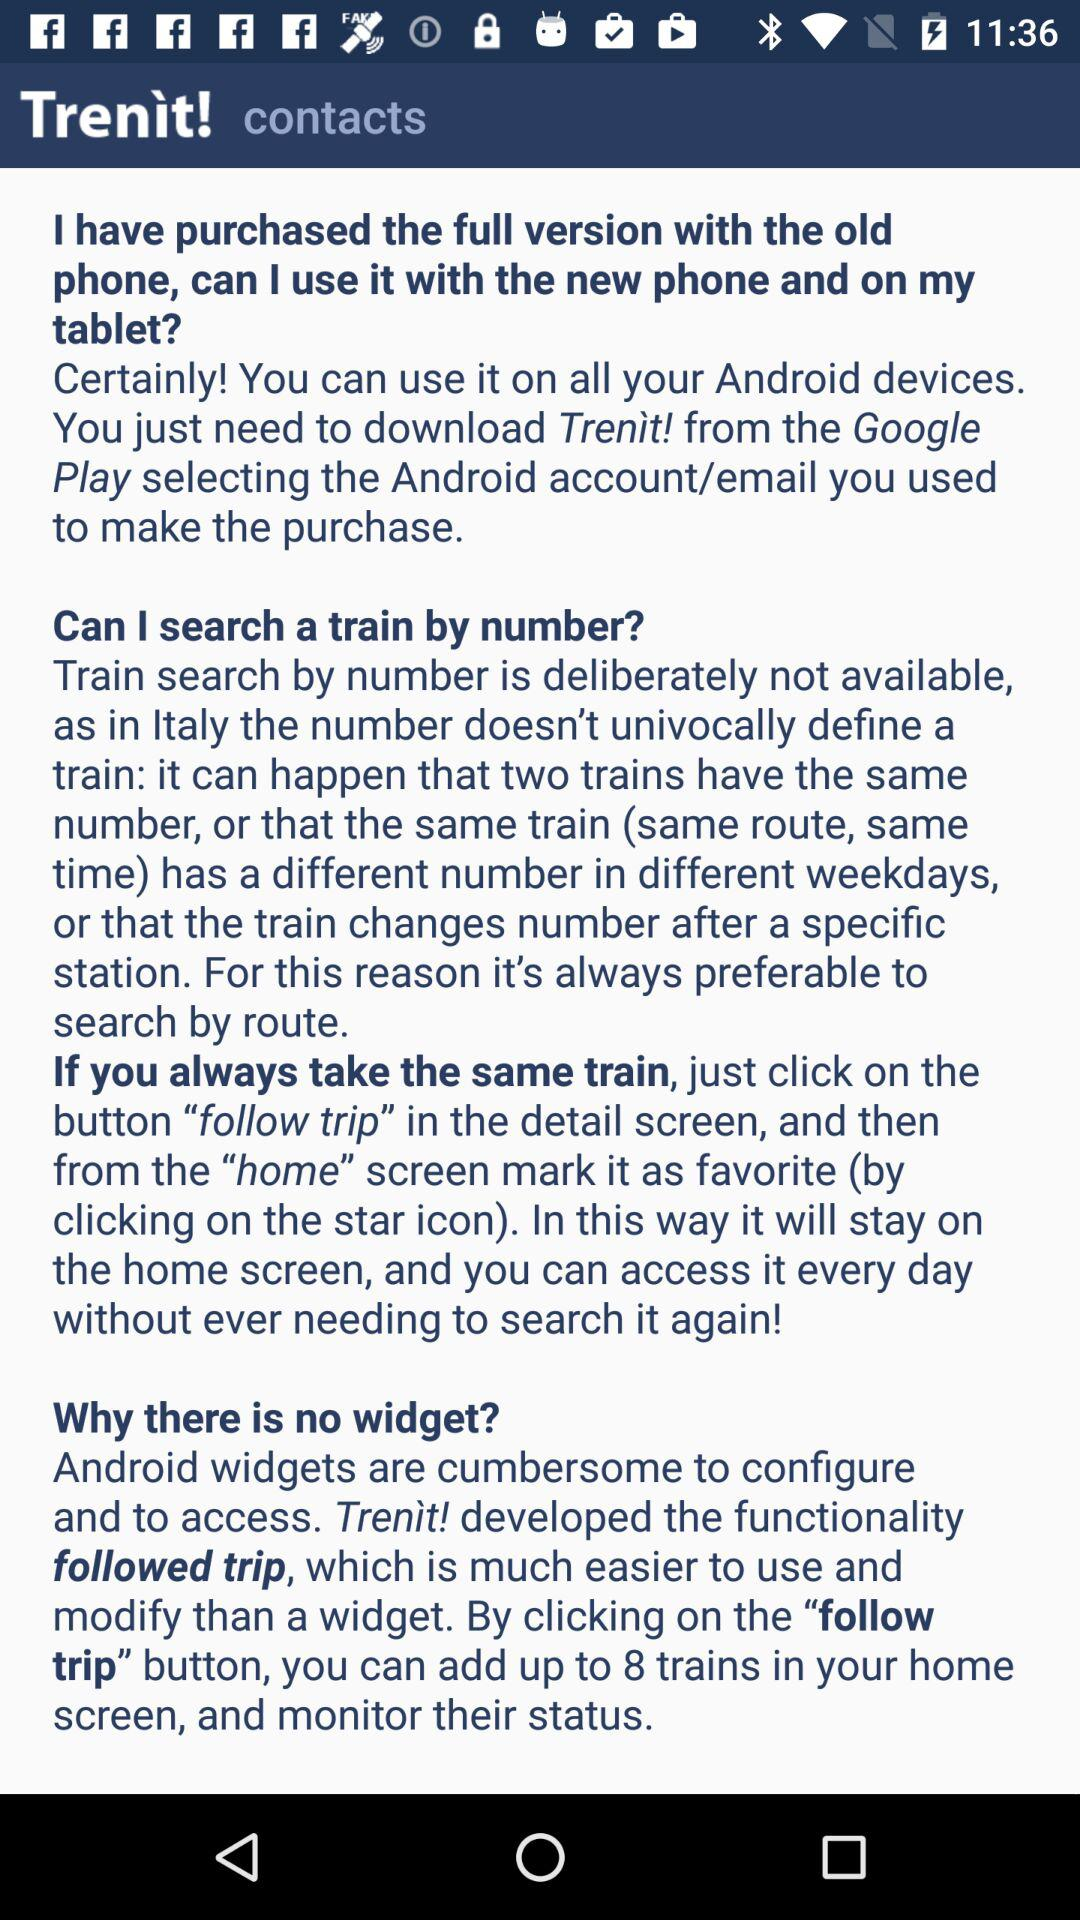How many answers does this FAQ have?
Answer the question using a single word or phrase. 3 